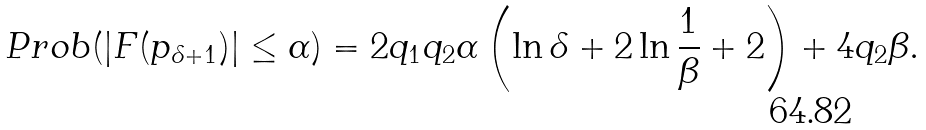Convert formula to latex. <formula><loc_0><loc_0><loc_500><loc_500>P r o b ( | F ( p _ { \delta + 1 } ) | \leq \alpha ) = 2 q _ { 1 } q _ { 2 } \alpha \left ( \ln \delta + 2 \ln \frac { 1 } { \beta } + 2 \right ) + 4 q _ { 2 } \beta .</formula> 